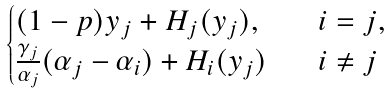Convert formula to latex. <formula><loc_0><loc_0><loc_500><loc_500>\begin{cases} ( 1 - p ) y _ { j } + H _ { j } ( y _ { j } ) , \quad & i = j , \\ \frac { \gamma _ { j } } { \alpha _ { j } } ( \alpha _ { j } - \alpha _ { i } ) + H _ { i } ( y _ { j } ) & i \ne j \end{cases}</formula> 